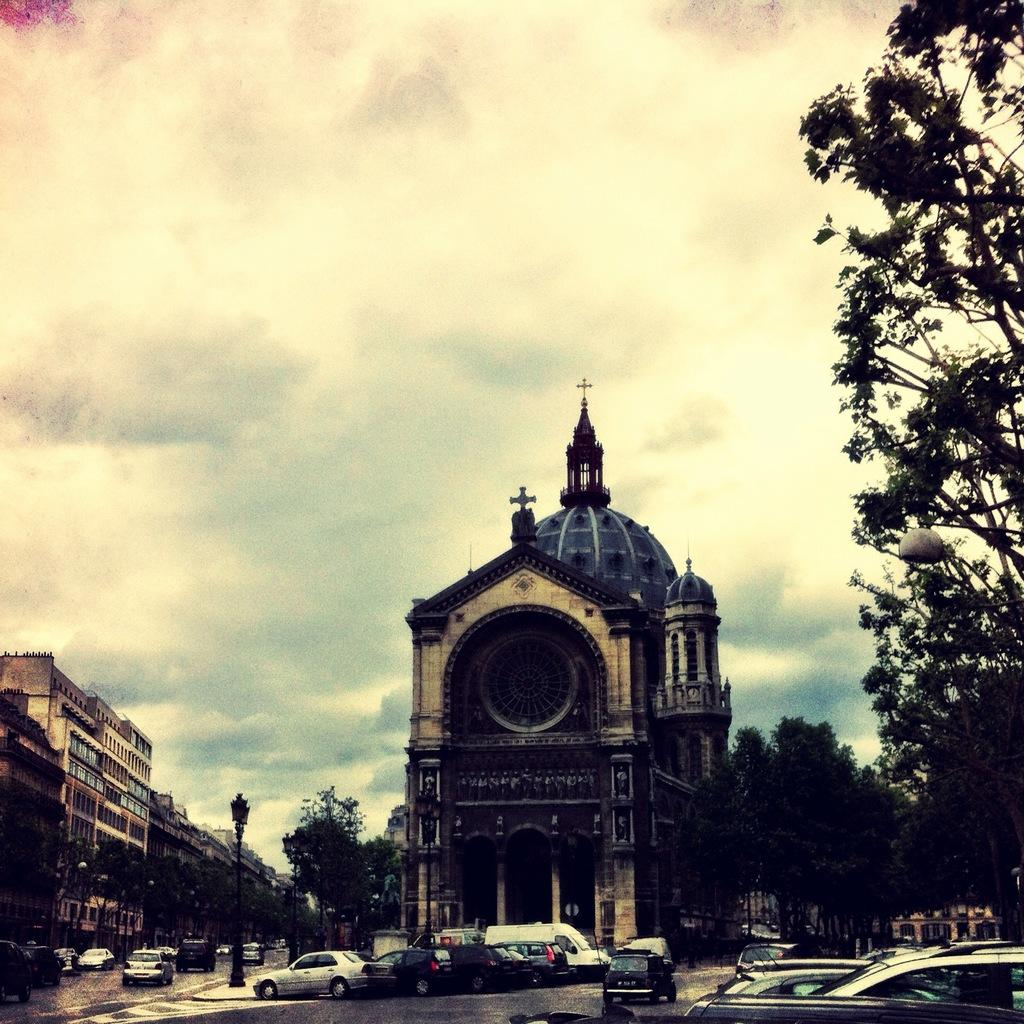What can be seen moving on the road in the image? There are cars on the road in the image. What type of structures are visible in the image? There are buildings in the image. What type of vegetation is present in the image? There are trees in the image. What object is standing upright in the image? There is a pole in the image. What can be seen in the background of the image? The sky with clouds is visible in the background of the image. Are there any fangs visible on the cars in the image? There are no fangs present in the image; it features cars on the road. Can you see a coach traveling on the road in the image? There is no coach visible on the road in the image; only cars are present. 